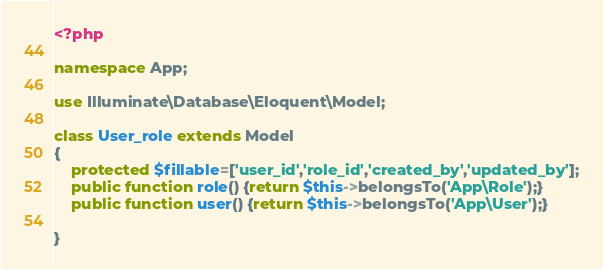Convert code to text. <code><loc_0><loc_0><loc_500><loc_500><_PHP_><?php

namespace App;

use Illuminate\Database\Eloquent\Model;

class User_role extends Model
{
    protected $fillable=['user_id','role_id','created_by','updated_by'];
    public function role() {return $this->belongsTo('App\Role');}
    public function user() {return $this->belongsTo('App\User');}

}
</code> 